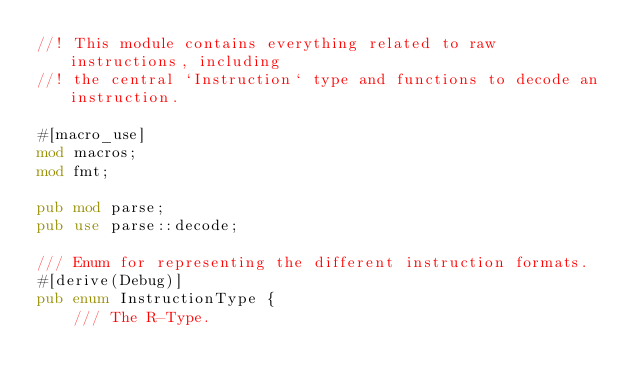<code> <loc_0><loc_0><loc_500><loc_500><_Rust_>//! This module contains everything related to raw instructions, including
//! the central `Instruction` type and functions to decode an instruction.

#[macro_use]
mod macros;
mod fmt;

pub mod parse;
pub use parse::decode;

/// Enum for representing the different instruction formats.
#[derive(Debug)]
pub enum InstructionType {
    /// The R-Type.</code> 